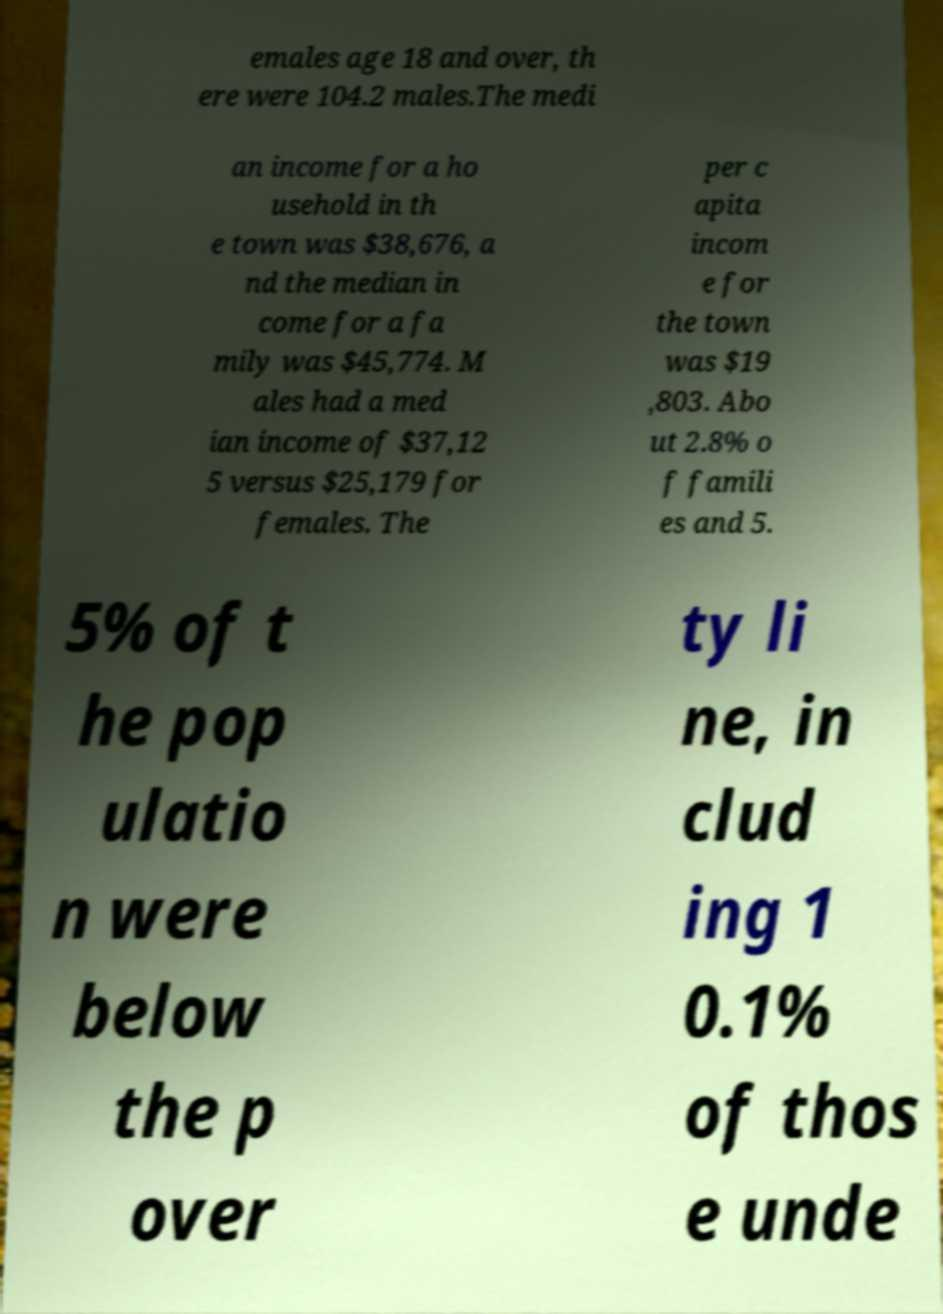Could you assist in decoding the text presented in this image and type it out clearly? emales age 18 and over, th ere were 104.2 males.The medi an income for a ho usehold in th e town was $38,676, a nd the median in come for a fa mily was $45,774. M ales had a med ian income of $37,12 5 versus $25,179 for females. The per c apita incom e for the town was $19 ,803. Abo ut 2.8% o f famili es and 5. 5% of t he pop ulatio n were below the p over ty li ne, in clud ing 1 0.1% of thos e unde 